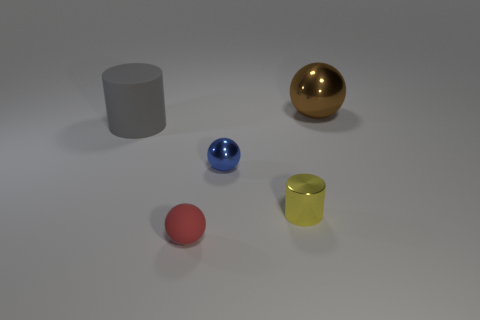Add 3 brown metal things. How many objects exist? 8 Subtract all spheres. How many objects are left? 2 Add 1 small metal balls. How many small metal balls are left? 2 Add 4 small gray metal objects. How many small gray metal objects exist? 4 Subtract 0 yellow spheres. How many objects are left? 5 Subtract all small gray metallic cylinders. Subtract all brown balls. How many objects are left? 4 